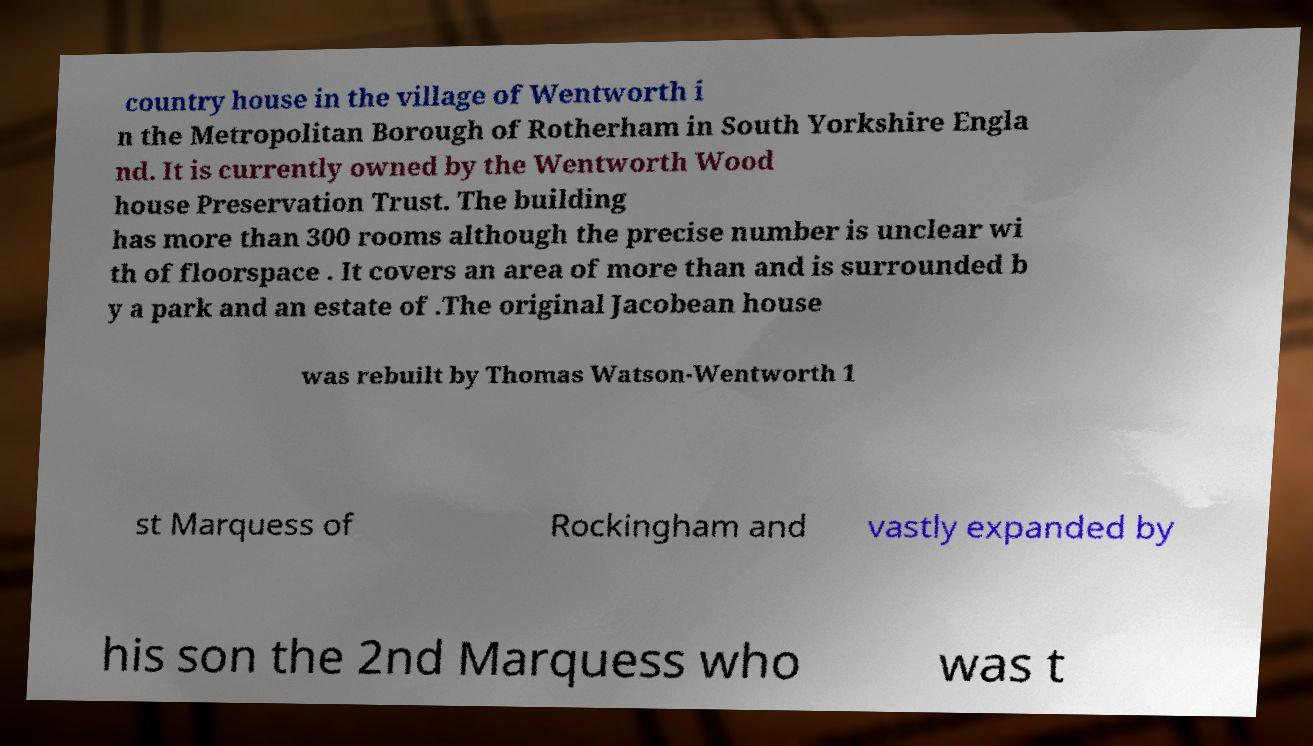I need the written content from this picture converted into text. Can you do that? country house in the village of Wentworth i n the Metropolitan Borough of Rotherham in South Yorkshire Engla nd. It is currently owned by the Wentworth Wood house Preservation Trust. The building has more than 300 rooms although the precise number is unclear wi th of floorspace . It covers an area of more than and is surrounded b y a park and an estate of .The original Jacobean house was rebuilt by Thomas Watson-Wentworth 1 st Marquess of Rockingham and vastly expanded by his son the 2nd Marquess who was t 